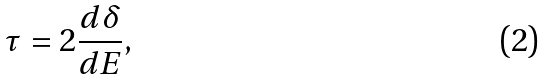<formula> <loc_0><loc_0><loc_500><loc_500>\tau = 2 \frac { d \delta } { d E } ,</formula> 